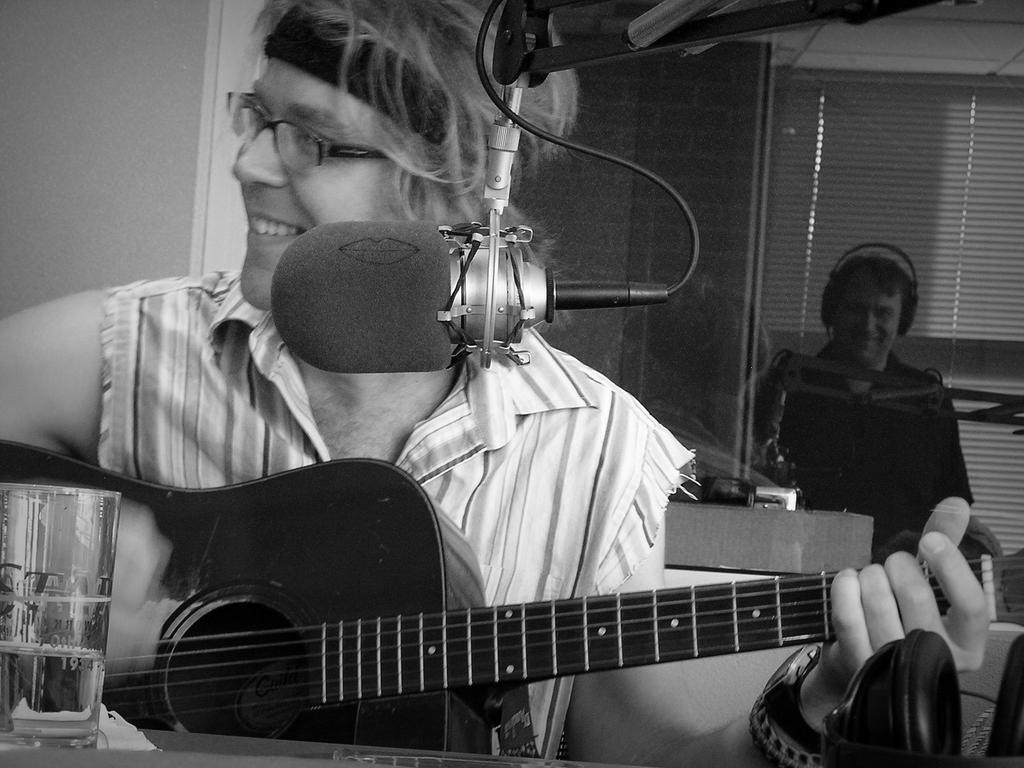Please provide a concise description of this image. A man is playing a guitar with a mic in front of him. 